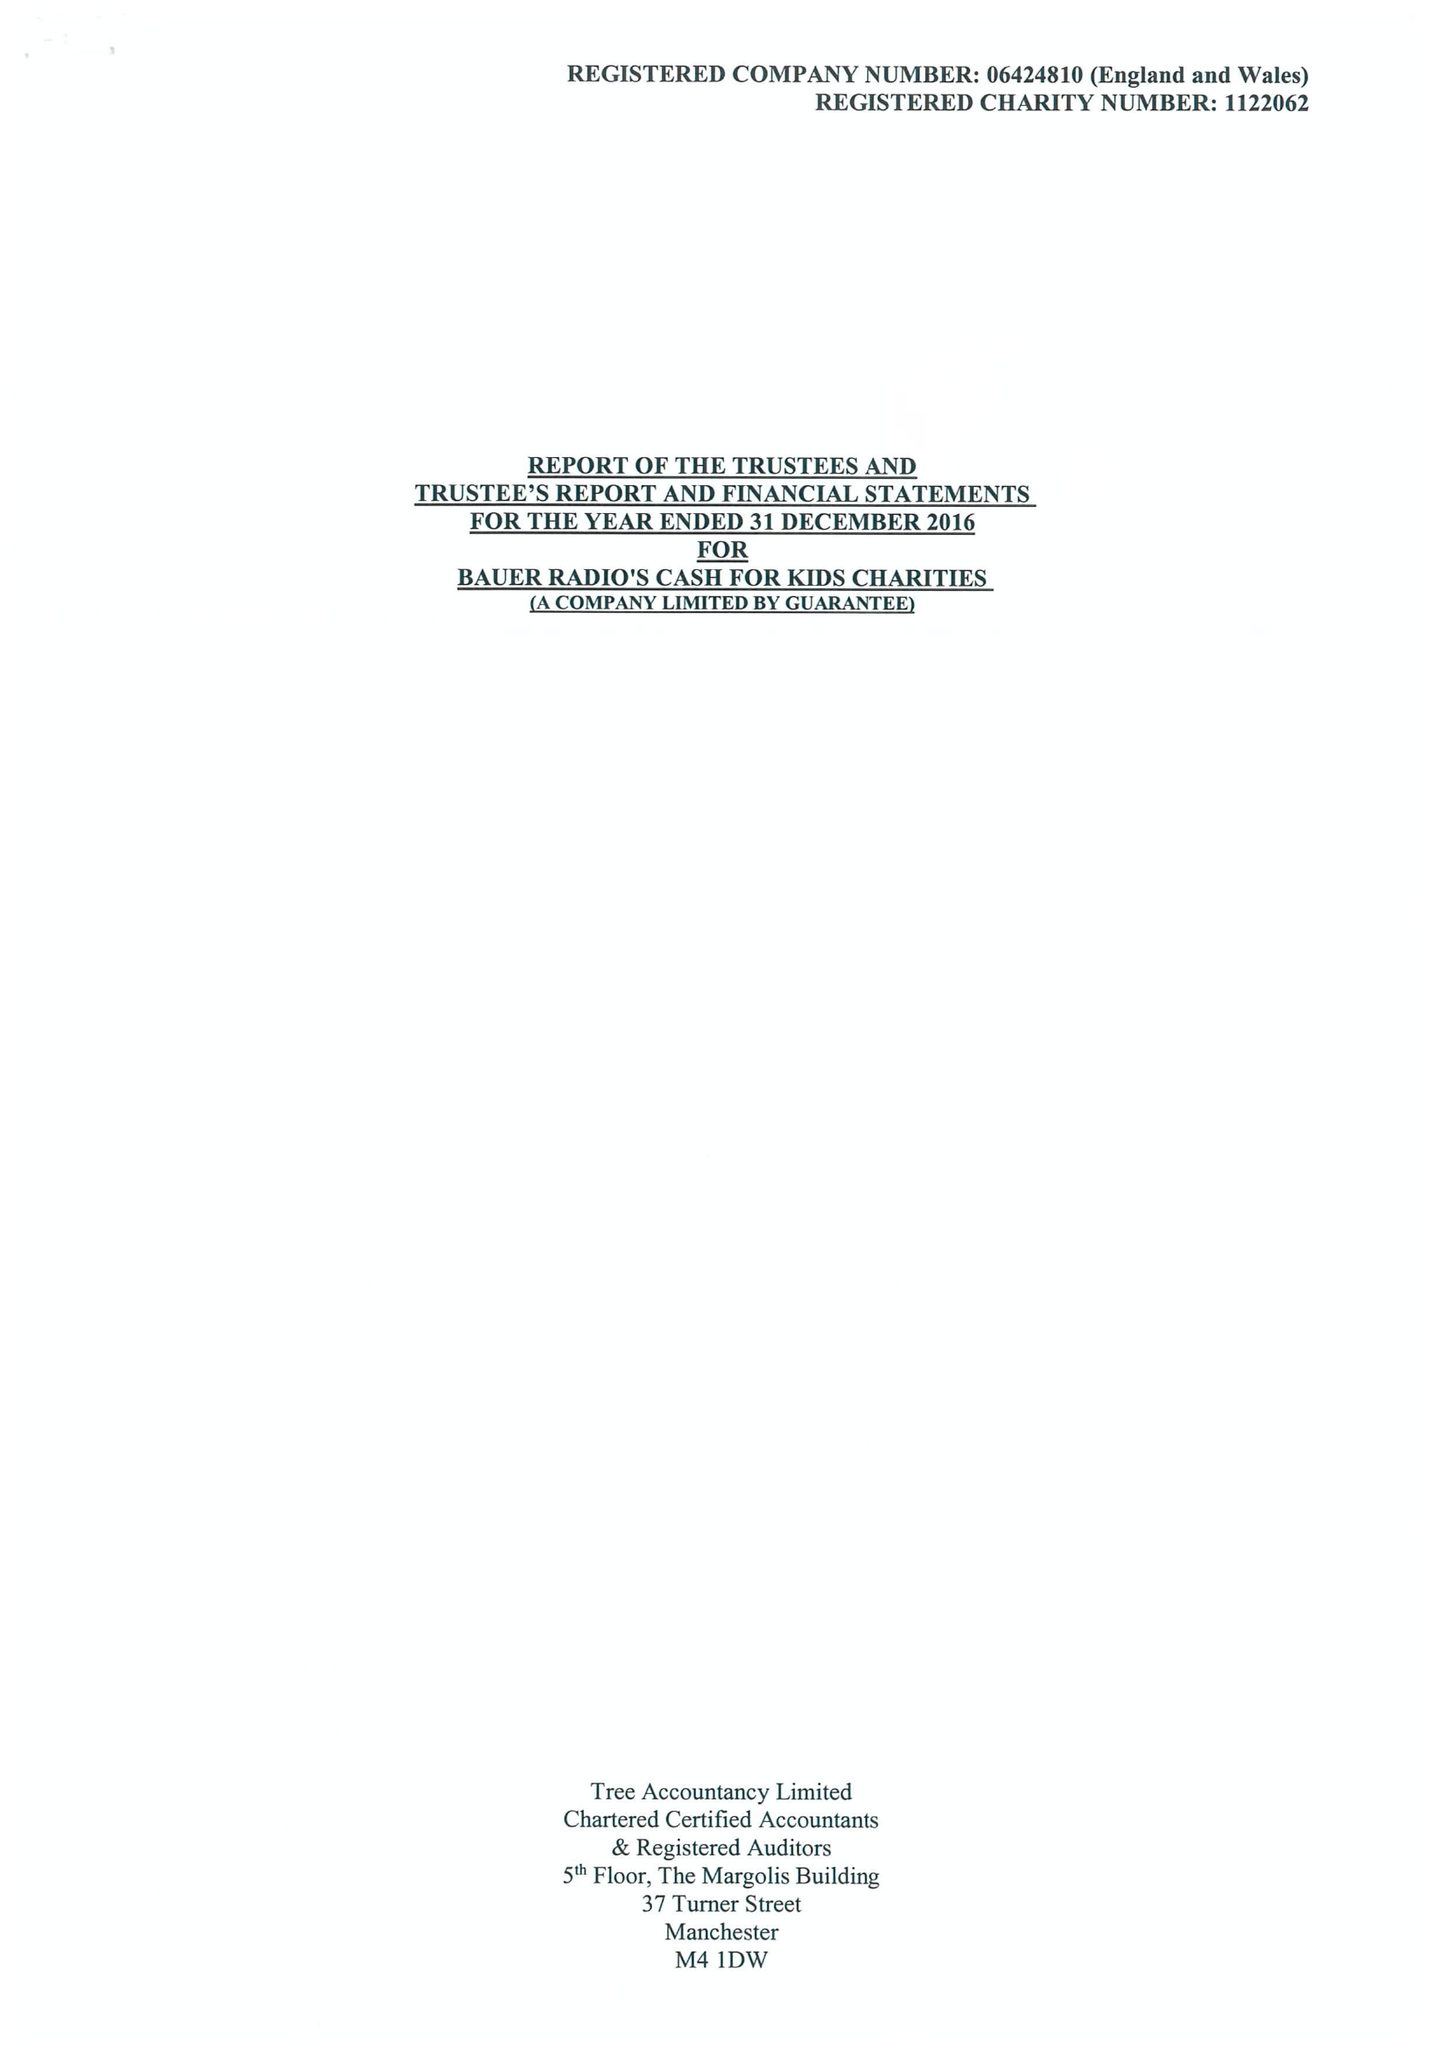What is the value for the income_annually_in_british_pounds?
Answer the question using a single word or phrase. 15699876.00 